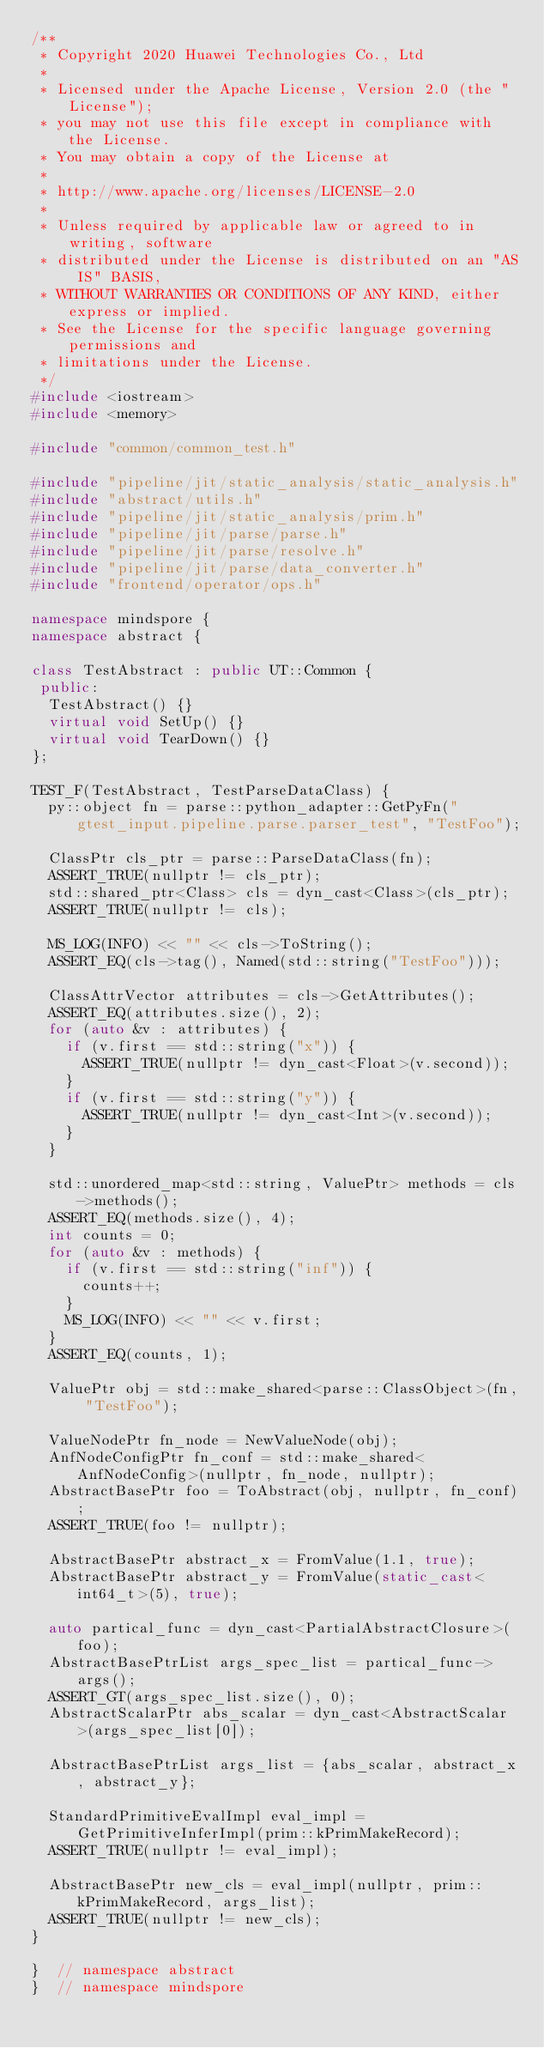Convert code to text. <code><loc_0><loc_0><loc_500><loc_500><_C++_>/**
 * Copyright 2020 Huawei Technologies Co., Ltd
 *
 * Licensed under the Apache License, Version 2.0 (the "License");
 * you may not use this file except in compliance with the License.
 * You may obtain a copy of the License at
 *
 * http://www.apache.org/licenses/LICENSE-2.0
 *
 * Unless required by applicable law or agreed to in writing, software
 * distributed under the License is distributed on an "AS IS" BASIS,
 * WITHOUT WARRANTIES OR CONDITIONS OF ANY KIND, either express or implied.
 * See the License for the specific language governing permissions and
 * limitations under the License.
 */
#include <iostream>
#include <memory>

#include "common/common_test.h"

#include "pipeline/jit/static_analysis/static_analysis.h"
#include "abstract/utils.h"
#include "pipeline/jit/static_analysis/prim.h"
#include "pipeline/jit/parse/parse.h"
#include "pipeline/jit/parse/resolve.h"
#include "pipeline/jit/parse/data_converter.h"
#include "frontend/operator/ops.h"

namespace mindspore {
namespace abstract {

class TestAbstract : public UT::Common {
 public:
  TestAbstract() {}
  virtual void SetUp() {}
  virtual void TearDown() {}
};

TEST_F(TestAbstract, TestParseDataClass) {
  py::object fn = parse::python_adapter::GetPyFn("gtest_input.pipeline.parse.parser_test", "TestFoo");

  ClassPtr cls_ptr = parse::ParseDataClass(fn);
  ASSERT_TRUE(nullptr != cls_ptr);
  std::shared_ptr<Class> cls = dyn_cast<Class>(cls_ptr);
  ASSERT_TRUE(nullptr != cls);

  MS_LOG(INFO) << "" << cls->ToString();
  ASSERT_EQ(cls->tag(), Named(std::string("TestFoo")));

  ClassAttrVector attributes = cls->GetAttributes();
  ASSERT_EQ(attributes.size(), 2);
  for (auto &v : attributes) {
    if (v.first == std::string("x")) {
      ASSERT_TRUE(nullptr != dyn_cast<Float>(v.second));
    }
    if (v.first == std::string("y")) {
      ASSERT_TRUE(nullptr != dyn_cast<Int>(v.second));
    }
  }

  std::unordered_map<std::string, ValuePtr> methods = cls->methods();
  ASSERT_EQ(methods.size(), 4);
  int counts = 0;
  for (auto &v : methods) {
    if (v.first == std::string("inf")) {
      counts++;
    }
    MS_LOG(INFO) << "" << v.first;
  }
  ASSERT_EQ(counts, 1);

  ValuePtr obj = std::make_shared<parse::ClassObject>(fn, "TestFoo");

  ValueNodePtr fn_node = NewValueNode(obj);
  AnfNodeConfigPtr fn_conf = std::make_shared<AnfNodeConfig>(nullptr, fn_node, nullptr);
  AbstractBasePtr foo = ToAbstract(obj, nullptr, fn_conf);
  ASSERT_TRUE(foo != nullptr);

  AbstractBasePtr abstract_x = FromValue(1.1, true);
  AbstractBasePtr abstract_y = FromValue(static_cast<int64_t>(5), true);

  auto partical_func = dyn_cast<PartialAbstractClosure>(foo);
  AbstractBasePtrList args_spec_list = partical_func->args();
  ASSERT_GT(args_spec_list.size(), 0);
  AbstractScalarPtr abs_scalar = dyn_cast<AbstractScalar>(args_spec_list[0]);

  AbstractBasePtrList args_list = {abs_scalar, abstract_x, abstract_y};

  StandardPrimitiveEvalImpl eval_impl = GetPrimitiveInferImpl(prim::kPrimMakeRecord);
  ASSERT_TRUE(nullptr != eval_impl);

  AbstractBasePtr new_cls = eval_impl(nullptr, prim::kPrimMakeRecord, args_list);
  ASSERT_TRUE(nullptr != new_cls);
}

}  // namespace abstract
}  // namespace mindspore
</code> 